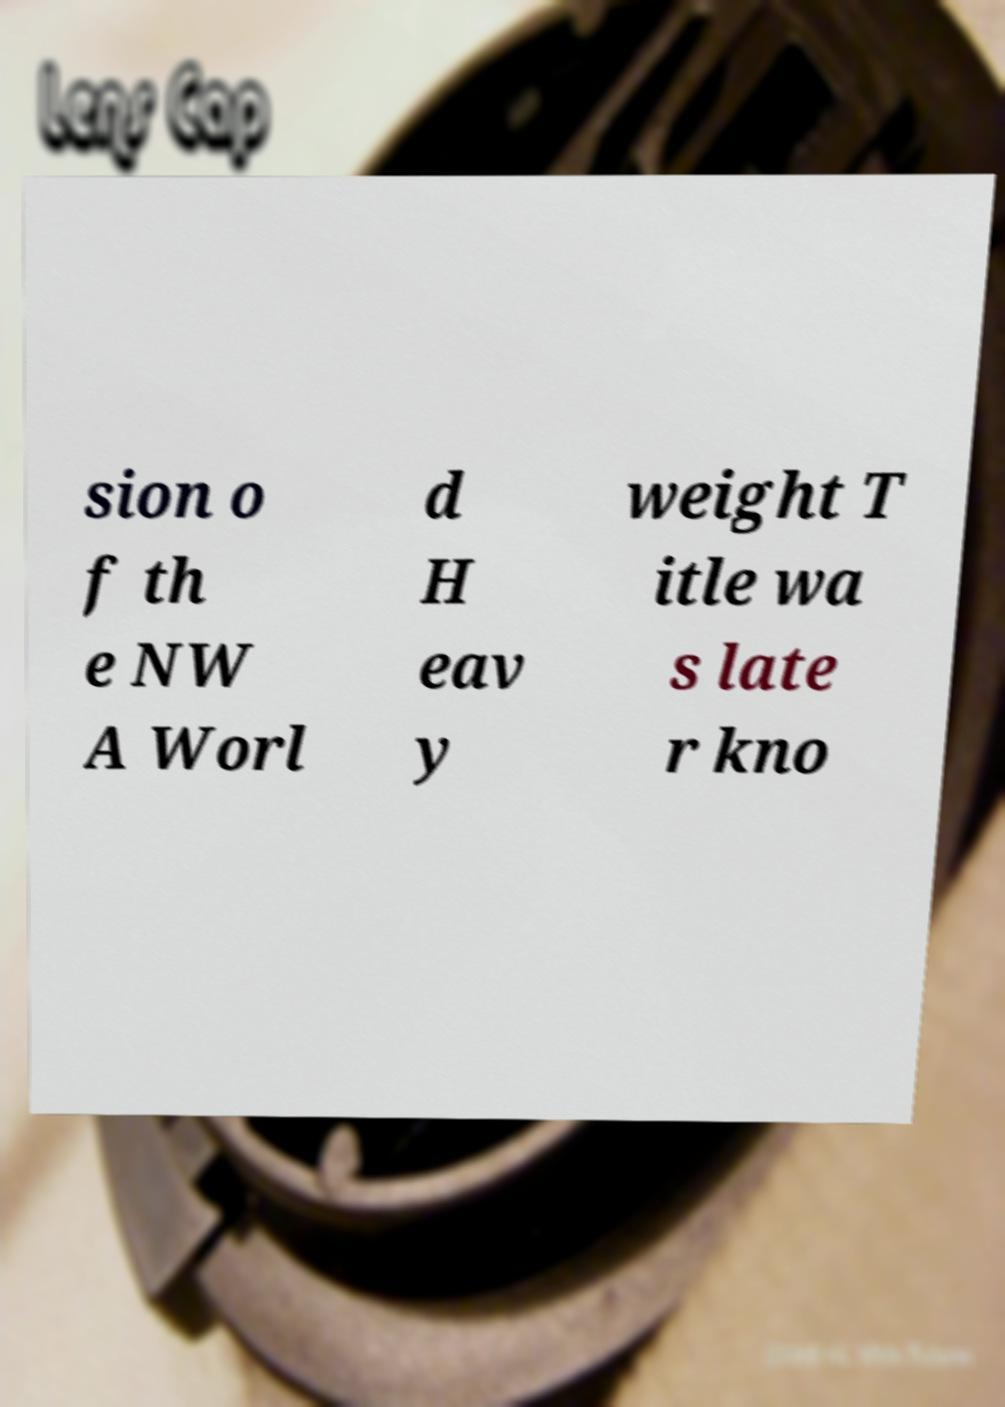There's text embedded in this image that I need extracted. Can you transcribe it verbatim? sion o f th e NW A Worl d H eav y weight T itle wa s late r kno 